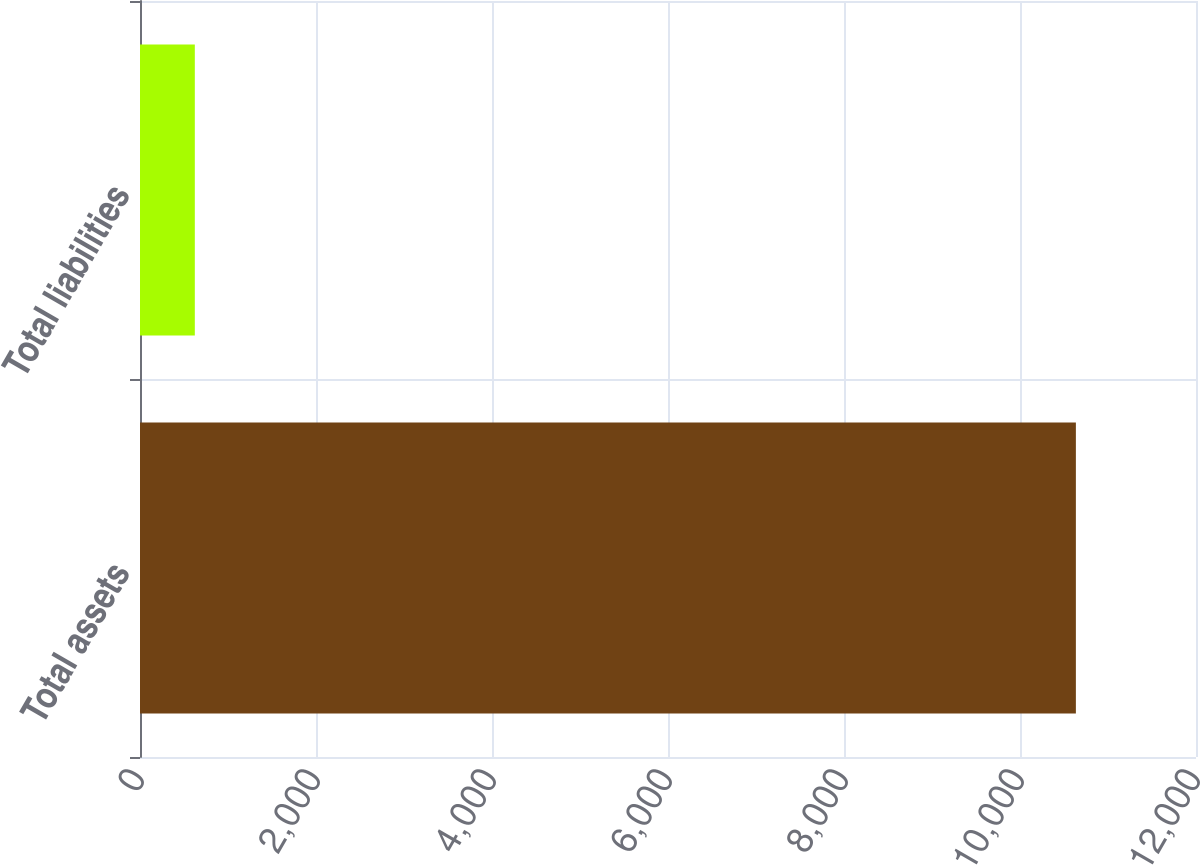Convert chart to OTSL. <chart><loc_0><loc_0><loc_500><loc_500><bar_chart><fcel>Total assets<fcel>Total liabilities<nl><fcel>10635<fcel>623<nl></chart> 